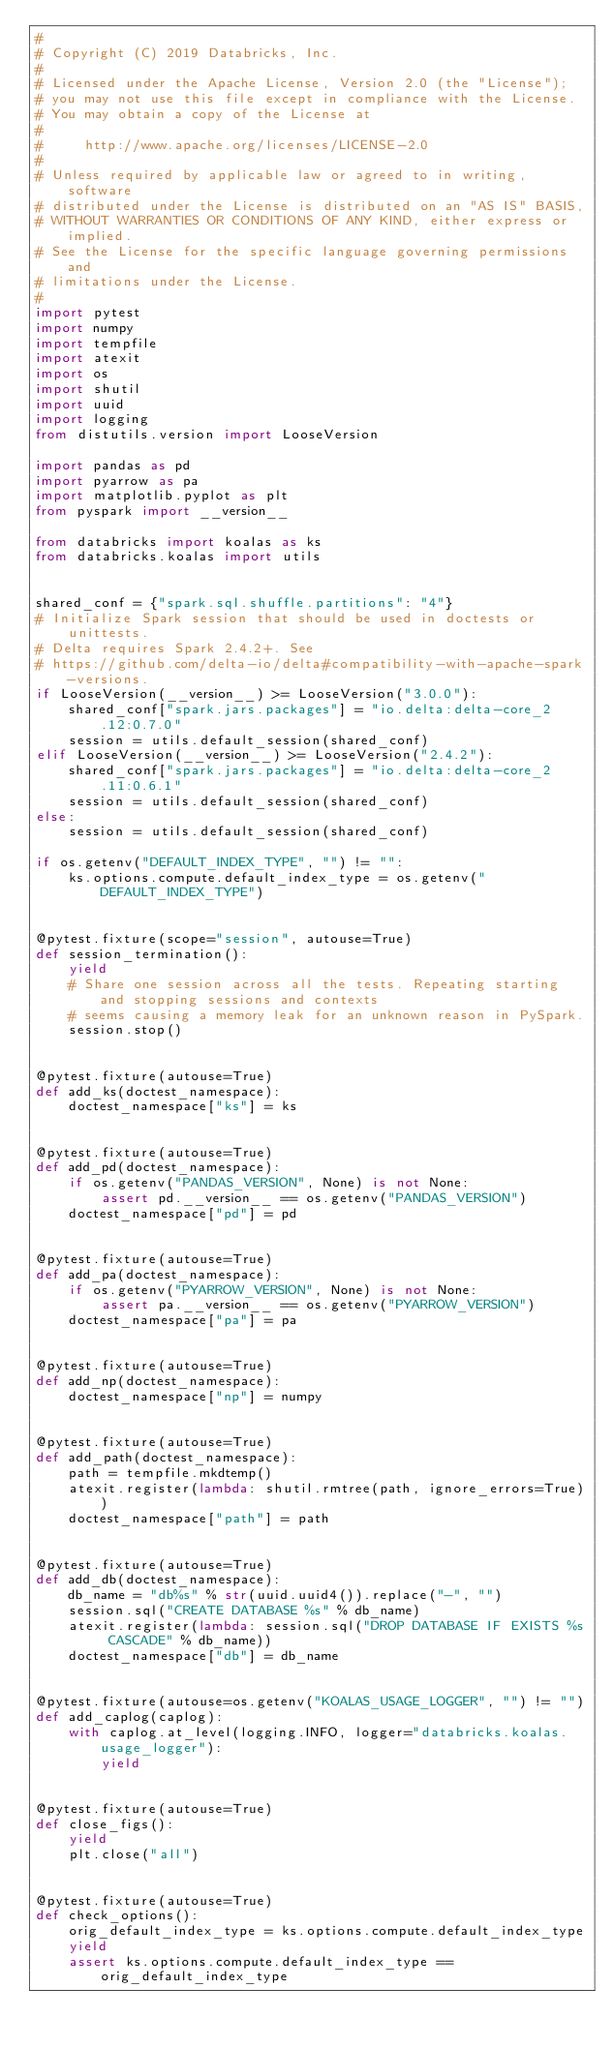<code> <loc_0><loc_0><loc_500><loc_500><_Python_>#
# Copyright (C) 2019 Databricks, Inc.
#
# Licensed under the Apache License, Version 2.0 (the "License");
# you may not use this file except in compliance with the License.
# You may obtain a copy of the License at
#
#     http://www.apache.org/licenses/LICENSE-2.0
#
# Unless required by applicable law or agreed to in writing, software
# distributed under the License is distributed on an "AS IS" BASIS,
# WITHOUT WARRANTIES OR CONDITIONS OF ANY KIND, either express or implied.
# See the License for the specific language governing permissions and
# limitations under the License.
#
import pytest
import numpy
import tempfile
import atexit
import os
import shutil
import uuid
import logging
from distutils.version import LooseVersion

import pandas as pd
import pyarrow as pa
import matplotlib.pyplot as plt
from pyspark import __version__

from databricks import koalas as ks
from databricks.koalas import utils


shared_conf = {"spark.sql.shuffle.partitions": "4"}
# Initialize Spark session that should be used in doctests or unittests.
# Delta requires Spark 2.4.2+. See
# https://github.com/delta-io/delta#compatibility-with-apache-spark-versions.
if LooseVersion(__version__) >= LooseVersion("3.0.0"):
    shared_conf["spark.jars.packages"] = "io.delta:delta-core_2.12:0.7.0"
    session = utils.default_session(shared_conf)
elif LooseVersion(__version__) >= LooseVersion("2.4.2"):
    shared_conf["spark.jars.packages"] = "io.delta:delta-core_2.11:0.6.1"
    session = utils.default_session(shared_conf)
else:
    session = utils.default_session(shared_conf)

if os.getenv("DEFAULT_INDEX_TYPE", "") != "":
    ks.options.compute.default_index_type = os.getenv("DEFAULT_INDEX_TYPE")


@pytest.fixture(scope="session", autouse=True)
def session_termination():
    yield
    # Share one session across all the tests. Repeating starting and stopping sessions and contexts
    # seems causing a memory leak for an unknown reason in PySpark.
    session.stop()


@pytest.fixture(autouse=True)
def add_ks(doctest_namespace):
    doctest_namespace["ks"] = ks


@pytest.fixture(autouse=True)
def add_pd(doctest_namespace):
    if os.getenv("PANDAS_VERSION", None) is not None:
        assert pd.__version__ == os.getenv("PANDAS_VERSION")
    doctest_namespace["pd"] = pd


@pytest.fixture(autouse=True)
def add_pa(doctest_namespace):
    if os.getenv("PYARROW_VERSION", None) is not None:
        assert pa.__version__ == os.getenv("PYARROW_VERSION")
    doctest_namespace["pa"] = pa


@pytest.fixture(autouse=True)
def add_np(doctest_namespace):
    doctest_namespace["np"] = numpy


@pytest.fixture(autouse=True)
def add_path(doctest_namespace):
    path = tempfile.mkdtemp()
    atexit.register(lambda: shutil.rmtree(path, ignore_errors=True))
    doctest_namespace["path"] = path


@pytest.fixture(autouse=True)
def add_db(doctest_namespace):
    db_name = "db%s" % str(uuid.uuid4()).replace("-", "")
    session.sql("CREATE DATABASE %s" % db_name)
    atexit.register(lambda: session.sql("DROP DATABASE IF EXISTS %s CASCADE" % db_name))
    doctest_namespace["db"] = db_name


@pytest.fixture(autouse=os.getenv("KOALAS_USAGE_LOGGER", "") != "")
def add_caplog(caplog):
    with caplog.at_level(logging.INFO, logger="databricks.koalas.usage_logger"):
        yield


@pytest.fixture(autouse=True)
def close_figs():
    yield
    plt.close("all")


@pytest.fixture(autouse=True)
def check_options():
    orig_default_index_type = ks.options.compute.default_index_type
    yield
    assert ks.options.compute.default_index_type == orig_default_index_type
</code> 